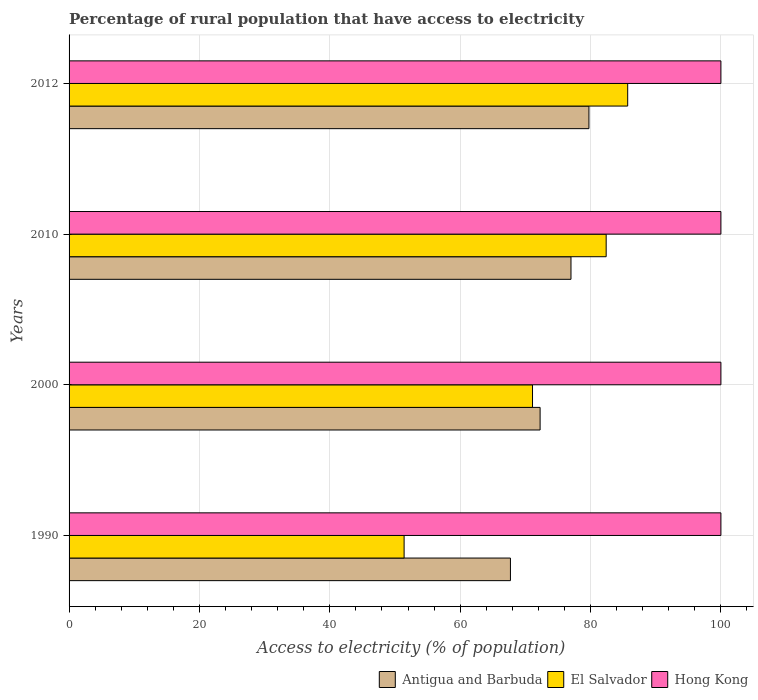How many different coloured bars are there?
Your answer should be compact. 3. What is the label of the 4th group of bars from the top?
Provide a short and direct response. 1990. What is the percentage of rural population that have access to electricity in Antigua and Barbuda in 2000?
Provide a short and direct response. 72.27. Across all years, what is the maximum percentage of rural population that have access to electricity in Hong Kong?
Provide a short and direct response. 100. Across all years, what is the minimum percentage of rural population that have access to electricity in Antigua and Barbuda?
Offer a terse response. 67.71. What is the total percentage of rural population that have access to electricity in Hong Kong in the graph?
Make the answer very short. 400. What is the difference between the percentage of rural population that have access to electricity in Hong Kong in 2000 and that in 2010?
Ensure brevity in your answer.  0. What is the difference between the percentage of rural population that have access to electricity in Hong Kong in 1990 and the percentage of rural population that have access to electricity in Antigua and Barbuda in 2012?
Offer a terse response. 20.25. What is the average percentage of rural population that have access to electricity in Antigua and Barbuda per year?
Ensure brevity in your answer.  74.18. In the year 2000, what is the difference between the percentage of rural population that have access to electricity in Hong Kong and percentage of rural population that have access to electricity in El Salvador?
Offer a terse response. 28.9. What is the ratio of the percentage of rural population that have access to electricity in Hong Kong in 2000 to that in 2012?
Your answer should be very brief. 1. Is the percentage of rural population that have access to electricity in El Salvador in 2010 less than that in 2012?
Ensure brevity in your answer.  Yes. Is the difference between the percentage of rural population that have access to electricity in Hong Kong in 2010 and 2012 greater than the difference between the percentage of rural population that have access to electricity in El Salvador in 2010 and 2012?
Provide a succinct answer. Yes. What is the difference between the highest and the second highest percentage of rural population that have access to electricity in El Salvador?
Keep it short and to the point. 3.3. What is the difference between the highest and the lowest percentage of rural population that have access to electricity in Antigua and Barbuda?
Offer a very short reply. 12.04. In how many years, is the percentage of rural population that have access to electricity in Antigua and Barbuda greater than the average percentage of rural population that have access to electricity in Antigua and Barbuda taken over all years?
Your answer should be very brief. 2. What does the 2nd bar from the top in 2010 represents?
Keep it short and to the point. El Salvador. What does the 3rd bar from the bottom in 2000 represents?
Ensure brevity in your answer.  Hong Kong. Is it the case that in every year, the sum of the percentage of rural population that have access to electricity in Hong Kong and percentage of rural population that have access to electricity in Antigua and Barbuda is greater than the percentage of rural population that have access to electricity in El Salvador?
Your response must be concise. Yes. How many bars are there?
Provide a short and direct response. 12. What is the difference between two consecutive major ticks on the X-axis?
Offer a very short reply. 20. Does the graph contain grids?
Give a very brief answer. Yes. Where does the legend appear in the graph?
Your answer should be compact. Bottom right. How many legend labels are there?
Give a very brief answer. 3. How are the legend labels stacked?
Give a very brief answer. Horizontal. What is the title of the graph?
Offer a terse response. Percentage of rural population that have access to electricity. Does "Philippines" appear as one of the legend labels in the graph?
Provide a succinct answer. No. What is the label or title of the X-axis?
Your answer should be compact. Access to electricity (% of population). What is the Access to electricity (% of population) in Antigua and Barbuda in 1990?
Keep it short and to the point. 67.71. What is the Access to electricity (% of population) of El Salvador in 1990?
Keep it short and to the point. 51.4. What is the Access to electricity (% of population) in Hong Kong in 1990?
Your answer should be compact. 100. What is the Access to electricity (% of population) in Antigua and Barbuda in 2000?
Your answer should be compact. 72.27. What is the Access to electricity (% of population) in El Salvador in 2000?
Make the answer very short. 71.1. What is the Access to electricity (% of population) of Hong Kong in 2000?
Your answer should be compact. 100. What is the Access to electricity (% of population) of El Salvador in 2010?
Offer a terse response. 82.4. What is the Access to electricity (% of population) of Hong Kong in 2010?
Offer a very short reply. 100. What is the Access to electricity (% of population) in Antigua and Barbuda in 2012?
Your answer should be very brief. 79.75. What is the Access to electricity (% of population) of El Salvador in 2012?
Ensure brevity in your answer.  85.7. Across all years, what is the maximum Access to electricity (% of population) in Antigua and Barbuda?
Provide a short and direct response. 79.75. Across all years, what is the maximum Access to electricity (% of population) of El Salvador?
Provide a short and direct response. 85.7. Across all years, what is the minimum Access to electricity (% of population) of Antigua and Barbuda?
Offer a very short reply. 67.71. Across all years, what is the minimum Access to electricity (% of population) of El Salvador?
Your answer should be compact. 51.4. Across all years, what is the minimum Access to electricity (% of population) in Hong Kong?
Your answer should be very brief. 100. What is the total Access to electricity (% of population) in Antigua and Barbuda in the graph?
Keep it short and to the point. 296.73. What is the total Access to electricity (% of population) in El Salvador in the graph?
Provide a succinct answer. 290.6. What is the difference between the Access to electricity (% of population) of Antigua and Barbuda in 1990 and that in 2000?
Offer a very short reply. -4.55. What is the difference between the Access to electricity (% of population) of El Salvador in 1990 and that in 2000?
Give a very brief answer. -19.7. What is the difference between the Access to electricity (% of population) in Antigua and Barbuda in 1990 and that in 2010?
Provide a succinct answer. -9.29. What is the difference between the Access to electricity (% of population) of El Salvador in 1990 and that in 2010?
Offer a terse response. -31. What is the difference between the Access to electricity (% of population) in Antigua and Barbuda in 1990 and that in 2012?
Make the answer very short. -12.04. What is the difference between the Access to electricity (% of population) in El Salvador in 1990 and that in 2012?
Your answer should be compact. -34.3. What is the difference between the Access to electricity (% of population) in Hong Kong in 1990 and that in 2012?
Provide a short and direct response. 0. What is the difference between the Access to electricity (% of population) in Antigua and Barbuda in 2000 and that in 2010?
Ensure brevity in your answer.  -4.74. What is the difference between the Access to electricity (% of population) in Antigua and Barbuda in 2000 and that in 2012?
Provide a succinct answer. -7.49. What is the difference between the Access to electricity (% of population) of El Salvador in 2000 and that in 2012?
Make the answer very short. -14.6. What is the difference between the Access to electricity (% of population) of Antigua and Barbuda in 2010 and that in 2012?
Your answer should be compact. -2.75. What is the difference between the Access to electricity (% of population) in Antigua and Barbuda in 1990 and the Access to electricity (% of population) in El Salvador in 2000?
Provide a short and direct response. -3.39. What is the difference between the Access to electricity (% of population) in Antigua and Barbuda in 1990 and the Access to electricity (% of population) in Hong Kong in 2000?
Ensure brevity in your answer.  -32.29. What is the difference between the Access to electricity (% of population) in El Salvador in 1990 and the Access to electricity (% of population) in Hong Kong in 2000?
Your answer should be very brief. -48.6. What is the difference between the Access to electricity (% of population) of Antigua and Barbuda in 1990 and the Access to electricity (% of population) of El Salvador in 2010?
Make the answer very short. -14.69. What is the difference between the Access to electricity (% of population) of Antigua and Barbuda in 1990 and the Access to electricity (% of population) of Hong Kong in 2010?
Your answer should be very brief. -32.29. What is the difference between the Access to electricity (% of population) of El Salvador in 1990 and the Access to electricity (% of population) of Hong Kong in 2010?
Ensure brevity in your answer.  -48.6. What is the difference between the Access to electricity (% of population) in Antigua and Barbuda in 1990 and the Access to electricity (% of population) in El Salvador in 2012?
Your answer should be very brief. -17.99. What is the difference between the Access to electricity (% of population) in Antigua and Barbuda in 1990 and the Access to electricity (% of population) in Hong Kong in 2012?
Your response must be concise. -32.29. What is the difference between the Access to electricity (% of population) in El Salvador in 1990 and the Access to electricity (% of population) in Hong Kong in 2012?
Make the answer very short. -48.6. What is the difference between the Access to electricity (% of population) in Antigua and Barbuda in 2000 and the Access to electricity (% of population) in El Salvador in 2010?
Your answer should be compact. -10.13. What is the difference between the Access to electricity (% of population) of Antigua and Barbuda in 2000 and the Access to electricity (% of population) of Hong Kong in 2010?
Offer a very short reply. -27.73. What is the difference between the Access to electricity (% of population) in El Salvador in 2000 and the Access to electricity (% of population) in Hong Kong in 2010?
Offer a terse response. -28.9. What is the difference between the Access to electricity (% of population) of Antigua and Barbuda in 2000 and the Access to electricity (% of population) of El Salvador in 2012?
Make the answer very short. -13.44. What is the difference between the Access to electricity (% of population) in Antigua and Barbuda in 2000 and the Access to electricity (% of population) in Hong Kong in 2012?
Your answer should be very brief. -27.73. What is the difference between the Access to electricity (% of population) of El Salvador in 2000 and the Access to electricity (% of population) of Hong Kong in 2012?
Your answer should be very brief. -28.9. What is the difference between the Access to electricity (% of population) in El Salvador in 2010 and the Access to electricity (% of population) in Hong Kong in 2012?
Offer a terse response. -17.6. What is the average Access to electricity (% of population) of Antigua and Barbuda per year?
Provide a succinct answer. 74.18. What is the average Access to electricity (% of population) in El Salvador per year?
Offer a terse response. 72.65. What is the average Access to electricity (% of population) in Hong Kong per year?
Provide a succinct answer. 100. In the year 1990, what is the difference between the Access to electricity (% of population) in Antigua and Barbuda and Access to electricity (% of population) in El Salvador?
Ensure brevity in your answer.  16.31. In the year 1990, what is the difference between the Access to electricity (% of population) in Antigua and Barbuda and Access to electricity (% of population) in Hong Kong?
Provide a short and direct response. -32.29. In the year 1990, what is the difference between the Access to electricity (% of population) of El Salvador and Access to electricity (% of population) of Hong Kong?
Give a very brief answer. -48.6. In the year 2000, what is the difference between the Access to electricity (% of population) in Antigua and Barbuda and Access to electricity (% of population) in El Salvador?
Give a very brief answer. 1.17. In the year 2000, what is the difference between the Access to electricity (% of population) in Antigua and Barbuda and Access to electricity (% of population) in Hong Kong?
Provide a succinct answer. -27.73. In the year 2000, what is the difference between the Access to electricity (% of population) of El Salvador and Access to electricity (% of population) of Hong Kong?
Keep it short and to the point. -28.9. In the year 2010, what is the difference between the Access to electricity (% of population) of Antigua and Barbuda and Access to electricity (% of population) of El Salvador?
Your answer should be very brief. -5.4. In the year 2010, what is the difference between the Access to electricity (% of population) in El Salvador and Access to electricity (% of population) in Hong Kong?
Offer a terse response. -17.6. In the year 2012, what is the difference between the Access to electricity (% of population) of Antigua and Barbuda and Access to electricity (% of population) of El Salvador?
Your answer should be very brief. -5.95. In the year 2012, what is the difference between the Access to electricity (% of population) of Antigua and Barbuda and Access to electricity (% of population) of Hong Kong?
Provide a short and direct response. -20.25. In the year 2012, what is the difference between the Access to electricity (% of population) in El Salvador and Access to electricity (% of population) in Hong Kong?
Provide a short and direct response. -14.3. What is the ratio of the Access to electricity (% of population) of Antigua and Barbuda in 1990 to that in 2000?
Your answer should be very brief. 0.94. What is the ratio of the Access to electricity (% of population) of El Salvador in 1990 to that in 2000?
Offer a terse response. 0.72. What is the ratio of the Access to electricity (% of population) in Hong Kong in 1990 to that in 2000?
Provide a short and direct response. 1. What is the ratio of the Access to electricity (% of population) of Antigua and Barbuda in 1990 to that in 2010?
Your answer should be compact. 0.88. What is the ratio of the Access to electricity (% of population) in El Salvador in 1990 to that in 2010?
Offer a terse response. 0.62. What is the ratio of the Access to electricity (% of population) in Antigua and Barbuda in 1990 to that in 2012?
Your answer should be very brief. 0.85. What is the ratio of the Access to electricity (% of population) in El Salvador in 1990 to that in 2012?
Your answer should be very brief. 0.6. What is the ratio of the Access to electricity (% of population) in Hong Kong in 1990 to that in 2012?
Offer a terse response. 1. What is the ratio of the Access to electricity (% of population) of Antigua and Barbuda in 2000 to that in 2010?
Give a very brief answer. 0.94. What is the ratio of the Access to electricity (% of population) in El Salvador in 2000 to that in 2010?
Offer a terse response. 0.86. What is the ratio of the Access to electricity (% of population) in Hong Kong in 2000 to that in 2010?
Provide a short and direct response. 1. What is the ratio of the Access to electricity (% of population) of Antigua and Barbuda in 2000 to that in 2012?
Give a very brief answer. 0.91. What is the ratio of the Access to electricity (% of population) of El Salvador in 2000 to that in 2012?
Your answer should be compact. 0.83. What is the ratio of the Access to electricity (% of population) of Antigua and Barbuda in 2010 to that in 2012?
Give a very brief answer. 0.97. What is the ratio of the Access to electricity (% of population) of El Salvador in 2010 to that in 2012?
Your answer should be compact. 0.96. What is the ratio of the Access to electricity (% of population) of Hong Kong in 2010 to that in 2012?
Ensure brevity in your answer.  1. What is the difference between the highest and the second highest Access to electricity (% of population) of Antigua and Barbuda?
Give a very brief answer. 2.75. What is the difference between the highest and the lowest Access to electricity (% of population) in Antigua and Barbuda?
Your answer should be compact. 12.04. What is the difference between the highest and the lowest Access to electricity (% of population) of El Salvador?
Your answer should be very brief. 34.3. What is the difference between the highest and the lowest Access to electricity (% of population) of Hong Kong?
Offer a terse response. 0. 